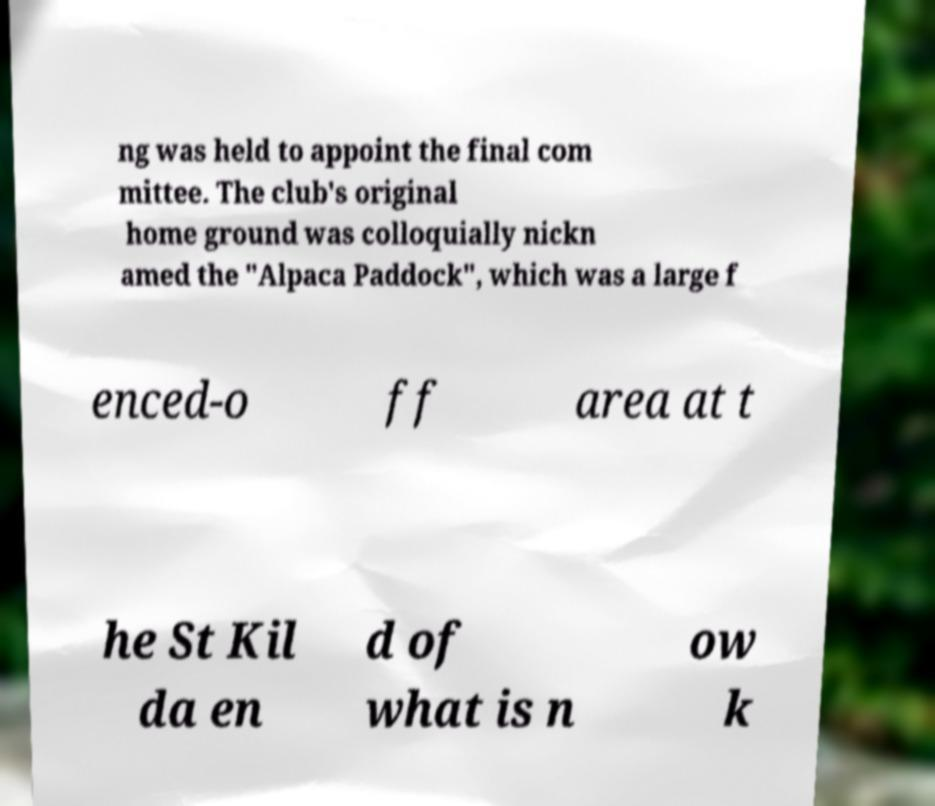Please identify and transcribe the text found in this image. ng was held to appoint the final com mittee. The club's original home ground was colloquially nickn amed the "Alpaca Paddock", which was a large f enced-o ff area at t he St Kil da en d of what is n ow k 